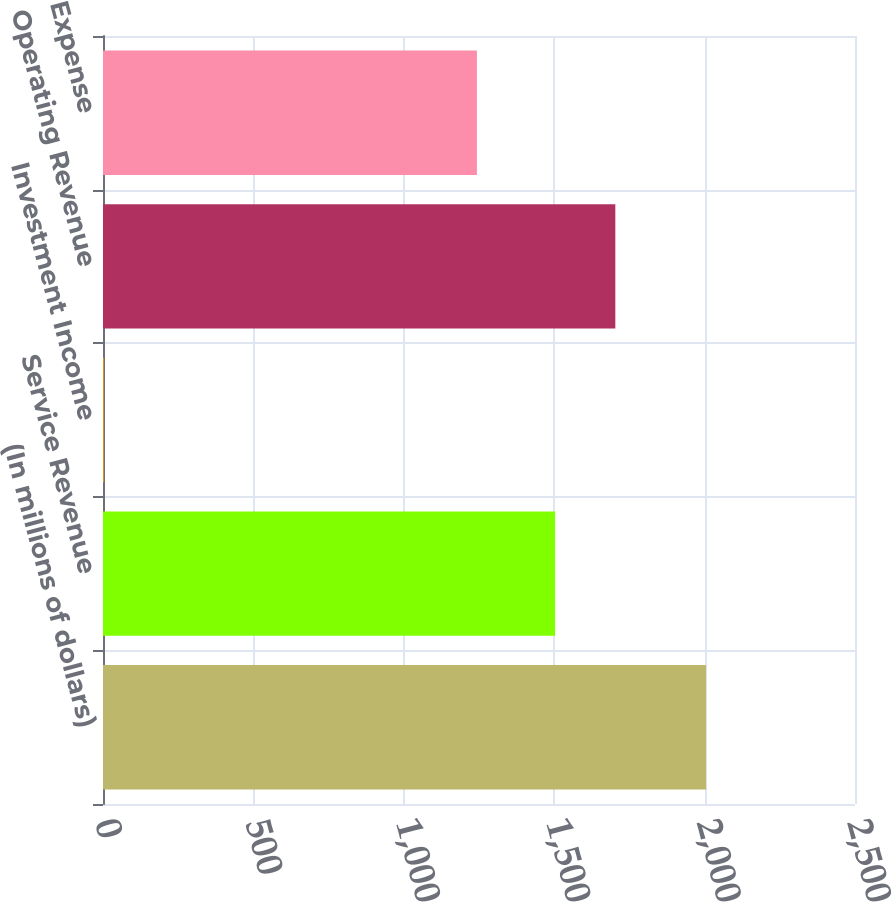Convert chart to OTSL. <chart><loc_0><loc_0><loc_500><loc_500><bar_chart><fcel>(In millions of dollars)<fcel>Service Revenue<fcel>Investment Income<fcel>Operating Revenue<fcel>Expense<nl><fcel>2005<fcel>1503<fcel>3<fcel>1703.2<fcel>1243<nl></chart> 